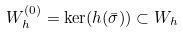<formula> <loc_0><loc_0><loc_500><loc_500>W ^ { ( 0 ) } _ { h } = \ker ( h ( \bar { \sigma } ) ) \subset W _ { h }</formula> 